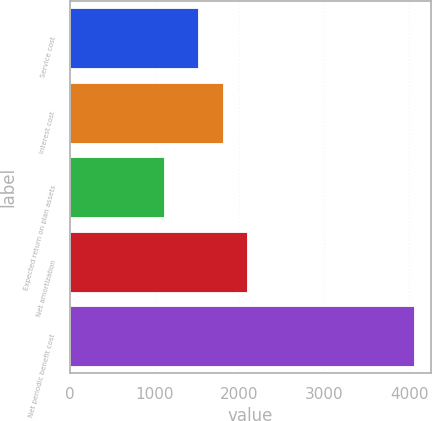Convert chart to OTSL. <chart><loc_0><loc_0><loc_500><loc_500><bar_chart><fcel>Service cost<fcel>Interest cost<fcel>Expected return on plan assets<fcel>Net amortization<fcel>Net periodic benefit cost<nl><fcel>1506<fcel>1800.3<fcel>1114<fcel>2094.6<fcel>4057<nl></chart> 